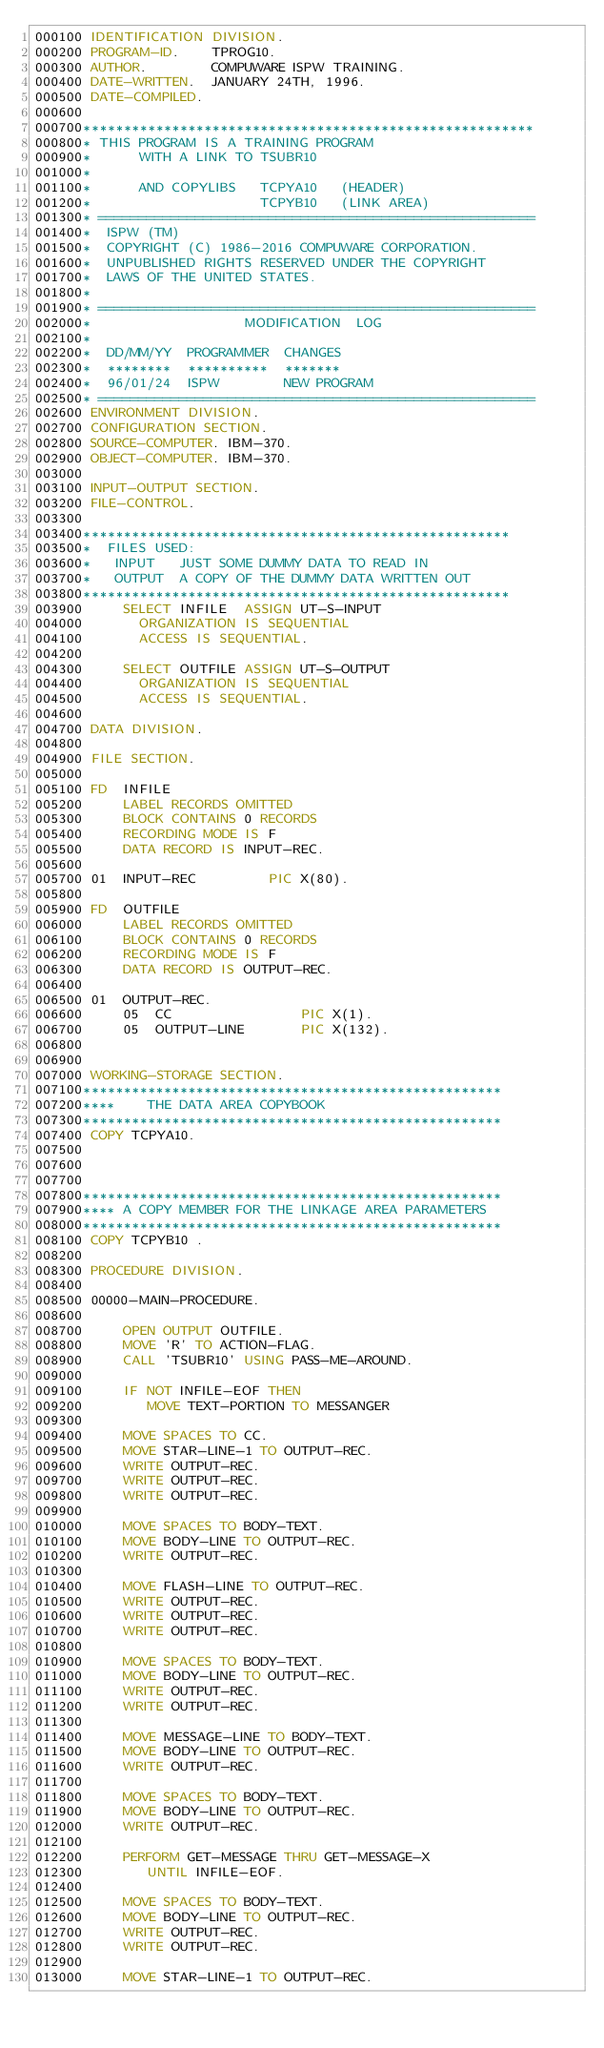<code> <loc_0><loc_0><loc_500><loc_500><_COBOL_>000100 IDENTIFICATION DIVISION.
000200 PROGRAM-ID.    TPROG10.
000300 AUTHOR.        COMPUWARE ISPW TRAINING.
000400 DATE-WRITTEN.  JANUARY 24TH, 1996.
000500 DATE-COMPILED.
000600
000700********************************************************
000800* THIS PROGRAM IS A TRAINING PROGRAM
000900*      WITH A LINK TO TSUBR10
001000*
001100*      AND COPYLIBS   TCPYA10   (HEADER)
001200*                     TCPYB10   (LINK AREA)
001300* ======================================================
001400*  ISPW (TM)
001500*  COPYRIGHT (C) 1986-2016 COMPUWARE CORPORATION.
001600*  UNPUBLISHED RIGHTS RESERVED UNDER THE COPYRIGHT
001700*  LAWS OF THE UNITED STATES.
001800*
001900* ======================================================
002000*                   MODIFICATION  LOG
002100*
002200*  DD/MM/YY  PROGRAMMER  CHANGES
002300*  ********  **********  *******
002400*  96/01/24  ISPW        NEW PROGRAM
002500* ======================================================
002600 ENVIRONMENT DIVISION.
002700 CONFIGURATION SECTION.
002800 SOURCE-COMPUTER. IBM-370.
002900 OBJECT-COMPUTER. IBM-370.
003000
003100 INPUT-OUTPUT SECTION.
003200 FILE-CONTROL.
003300
003400*****************************************************
003500*  FILES USED:
003600*   INPUT   JUST SOME DUMMY DATA TO READ IN
003700*   OUTPUT  A COPY OF THE DUMMY DATA WRITTEN OUT
003800*****************************************************
003900     SELECT INFILE  ASSIGN UT-S-INPUT
004000       ORGANIZATION IS SEQUENTIAL
004100       ACCESS IS SEQUENTIAL.
004200
004300     SELECT OUTFILE ASSIGN UT-S-OUTPUT
004400       ORGANIZATION IS SEQUENTIAL
004500       ACCESS IS SEQUENTIAL.
004600
004700 DATA DIVISION.
004800
004900 FILE SECTION.
005000
005100 FD  INFILE
005200     LABEL RECORDS OMITTED
005300     BLOCK CONTAINS 0 RECORDS
005400     RECORDING MODE IS F
005500     DATA RECORD IS INPUT-REC.
005600
005700 01  INPUT-REC         PIC X(80).
005800
005900 FD  OUTFILE
006000     LABEL RECORDS OMITTED
006100     BLOCK CONTAINS 0 RECORDS
006200     RECORDING MODE IS F
006300     DATA RECORD IS OUTPUT-REC.
006400
006500 01  OUTPUT-REC.
006600     05  CC                PIC X(1).
006700     05  OUTPUT-LINE       PIC X(132).
006800
006900
007000 WORKING-STORAGE SECTION.
007100****************************************************
007200****    THE DATA AREA COPYBOOK
007300****************************************************
007400 COPY TCPYA10.
007500
007600
007700
007800****************************************************
007900**** A COPY MEMBER FOR THE LINKAGE AREA PARAMETERS
008000****************************************************
008100 COPY TCPYB10 .
008200
008300 PROCEDURE DIVISION.
008400
008500 00000-MAIN-PROCEDURE.
008600
008700     OPEN OUTPUT OUTFILE.
008800     MOVE 'R' TO ACTION-FLAG.
008900     CALL 'TSUBR10' USING PASS-ME-AROUND.
009000
009100     IF NOT INFILE-EOF THEN
009200        MOVE TEXT-PORTION TO MESSANGER
009300
009400     MOVE SPACES TO CC.
009500     MOVE STAR-LINE-1 TO OUTPUT-REC.
009600     WRITE OUTPUT-REC.
009700     WRITE OUTPUT-REC.
009800     WRITE OUTPUT-REC.
009900
010000     MOVE SPACES TO BODY-TEXT.
010100     MOVE BODY-LINE TO OUTPUT-REC.
010200     WRITE OUTPUT-REC.
010300
010400     MOVE FLASH-LINE TO OUTPUT-REC.
010500     WRITE OUTPUT-REC.
010600     WRITE OUTPUT-REC.
010700     WRITE OUTPUT-REC.
010800
010900     MOVE SPACES TO BODY-TEXT.
011000     MOVE BODY-LINE TO OUTPUT-REC.
011100     WRITE OUTPUT-REC.
011200     WRITE OUTPUT-REC.
011300
011400     MOVE MESSAGE-LINE TO BODY-TEXT.
011500     MOVE BODY-LINE TO OUTPUT-REC.
011600     WRITE OUTPUT-REC.
011700
011800     MOVE SPACES TO BODY-TEXT.
011900     MOVE BODY-LINE TO OUTPUT-REC.
012000     WRITE OUTPUT-REC.
012100
012200     PERFORM GET-MESSAGE THRU GET-MESSAGE-X
012300        UNTIL INFILE-EOF.
012400
012500     MOVE SPACES TO BODY-TEXT.
012600     MOVE BODY-LINE TO OUTPUT-REC.
012700     WRITE OUTPUT-REC.
012800     WRITE OUTPUT-REC.
012900
013000     MOVE STAR-LINE-1 TO OUTPUT-REC.</code> 